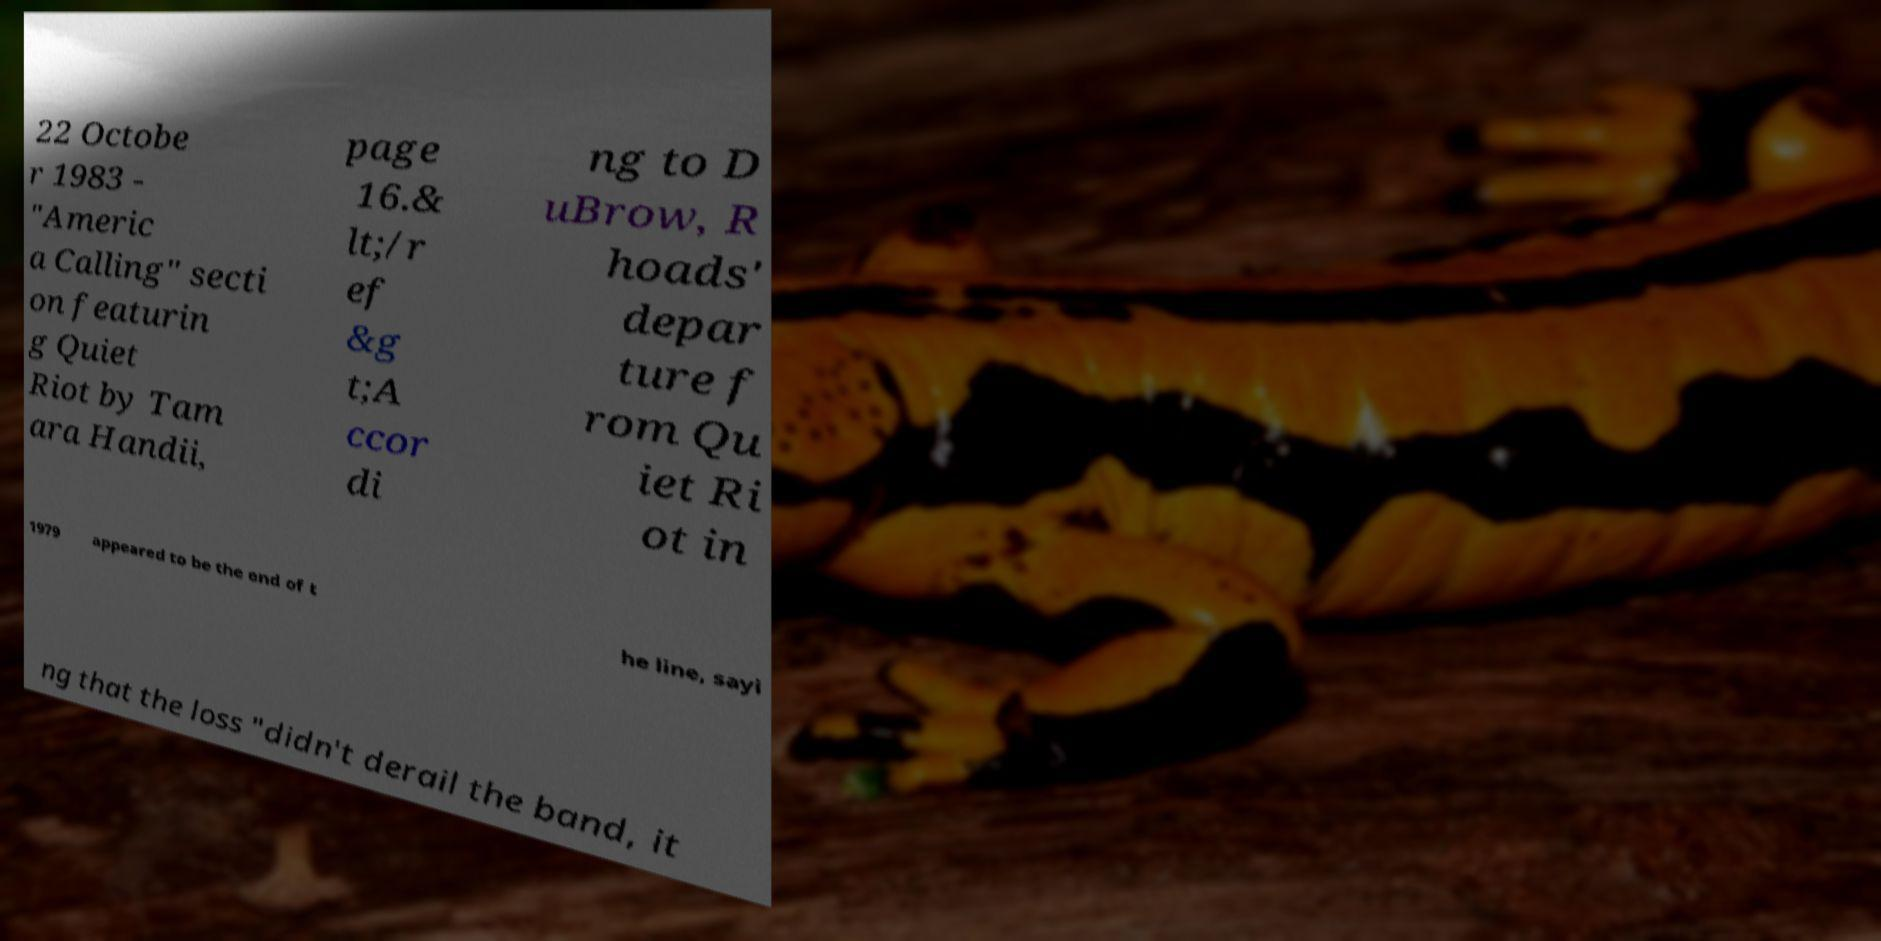Can you accurately transcribe the text from the provided image for me? 22 Octobe r 1983 - "Americ a Calling" secti on featurin g Quiet Riot by Tam ara Handii, page 16.& lt;/r ef &g t;A ccor di ng to D uBrow, R hoads' depar ture f rom Qu iet Ri ot in 1979 appeared to be the end of t he line, sayi ng that the loss "didn't derail the band, it 